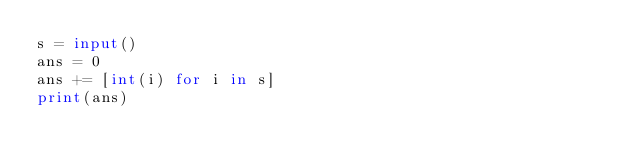Convert code to text. <code><loc_0><loc_0><loc_500><loc_500><_Python_>s = input()
ans = 0
ans += [int(i) for i in s]
print(ans)</code> 